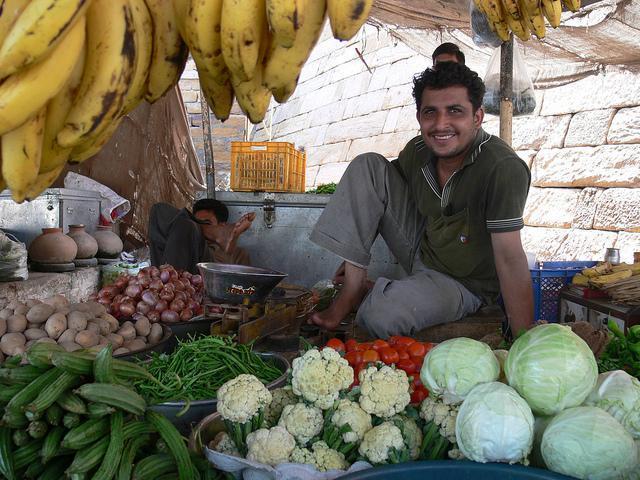How many types of fruit is this man selling?
Give a very brief answer. 1. How many bananas are in the photo?
Give a very brief answer. 4. How many people are visible?
Give a very brief answer. 2. 